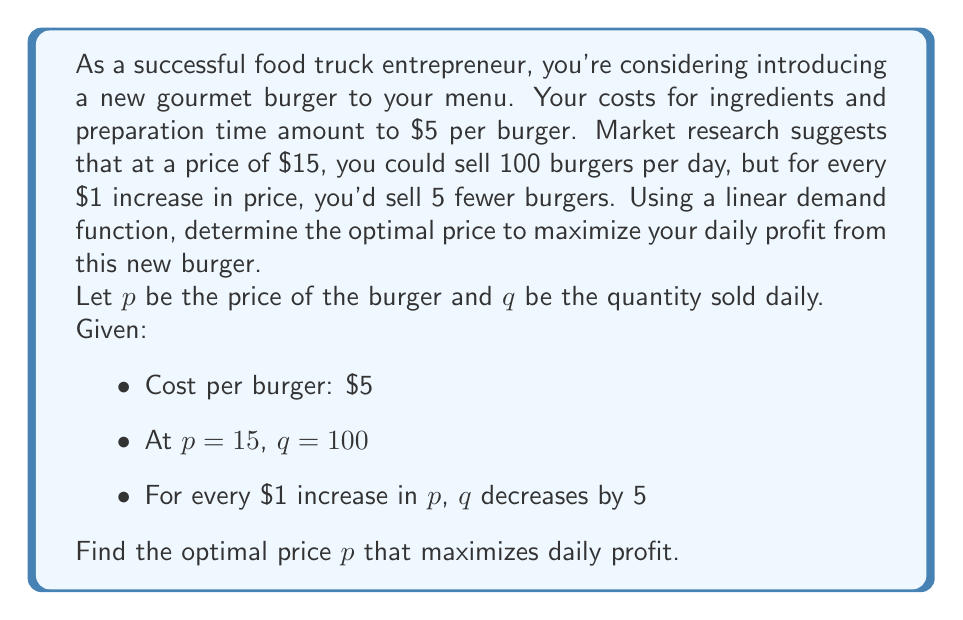Provide a solution to this math problem. Let's approach this step-by-step:

1) First, we need to formulate the demand function. We know that when $p = 15$, $q = 100$, and for every $1 increase in $p$, $q$ decreases by 5. This gives us a linear demand function:

   $q = 175 - 5p$

2) The revenue function $R$ is price times quantity:

   $R = pq = p(175 - 5p) = 175p - 5p^2$

3) The cost function $C$ is the cost per unit times the quantity:

   $C = 5q = 5(175 - 5p) = 875 - 25p$

4) The profit function $P$ is revenue minus cost:

   $P = R - C = (175p - 5p^2) - (875 - 25p) = -5p^2 + 200p - 875$

5) To find the maximum profit, we need to find where the derivative of $P$ with respect to $p$ is zero:

   $\frac{dP}{dp} = -10p + 200 = 0$

6) Solving this equation:

   $-10p + 200 = 0$
   $-10p = -200$
   $p = 20$

7) To confirm this is a maximum, we can check the second derivative:

   $\frac{d^2P}{dp^2} = -10$

   Since this is negative, we confirm that $p = 20$ gives a maximum profit.

8) At $p = 20$, the quantity sold is:

   $q = 175 - 5(20) = 75$

9) The maximum daily profit is:

   $P = -5(20)^2 + 200(20) - 875 = -2000 + 4000 - 875 = 1125$
Answer: The optimal price to maximize daily profit is $20 per burger. At this price, 75 burgers will be sold daily, resulting in a maximum daily profit of $1125. 